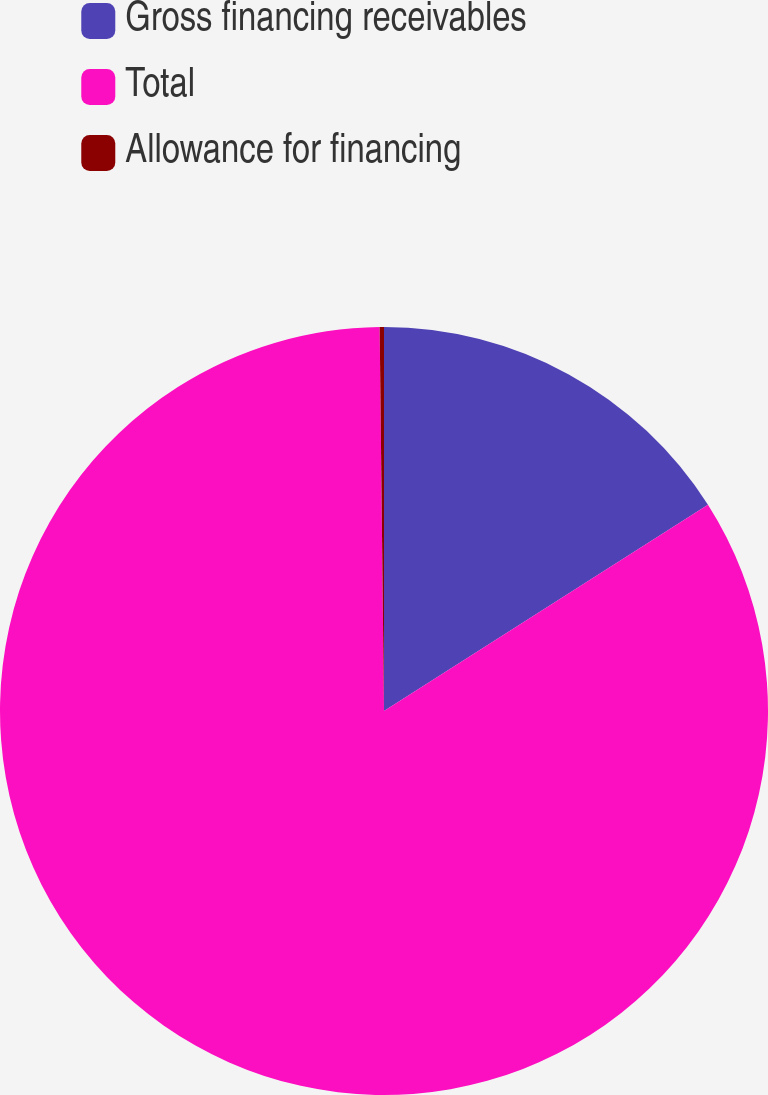Convert chart to OTSL. <chart><loc_0><loc_0><loc_500><loc_500><pie_chart><fcel>Gross financing receivables<fcel>Total<fcel>Allowance for financing<nl><fcel>15.98%<fcel>83.84%<fcel>0.18%<nl></chart> 